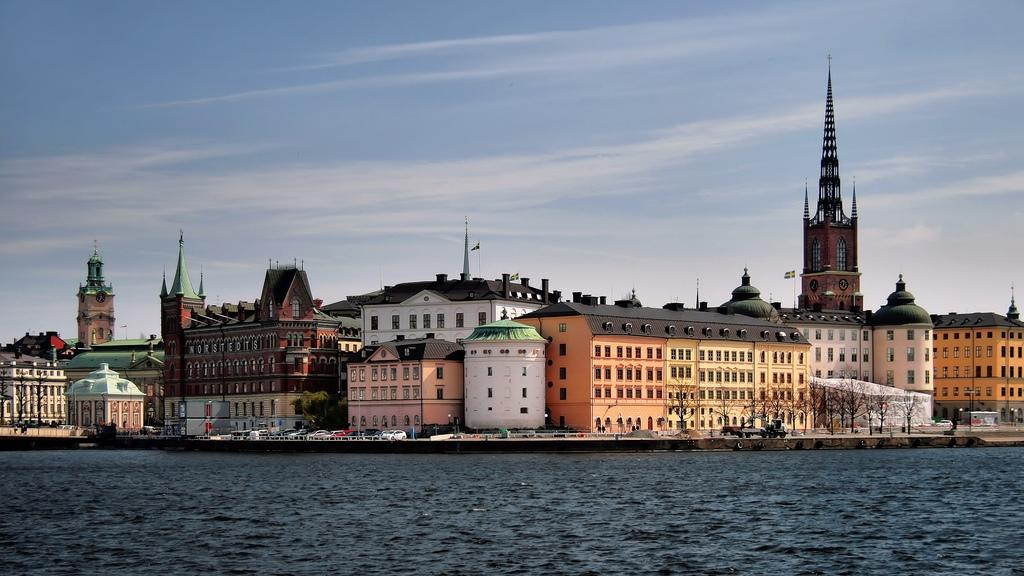What is located in the foreground of the image? There is a water body in the foreground of the image. What can be seen in the middle of the image? There is a building and cars in the middle of the image, along with a road. What is visible at the top of the image? The sky is visible at the top of the image. How many trees are used to measure the distance between the water body and the building in the image? There are no trees present in the image, and trees are not used to measure distances in this context. 